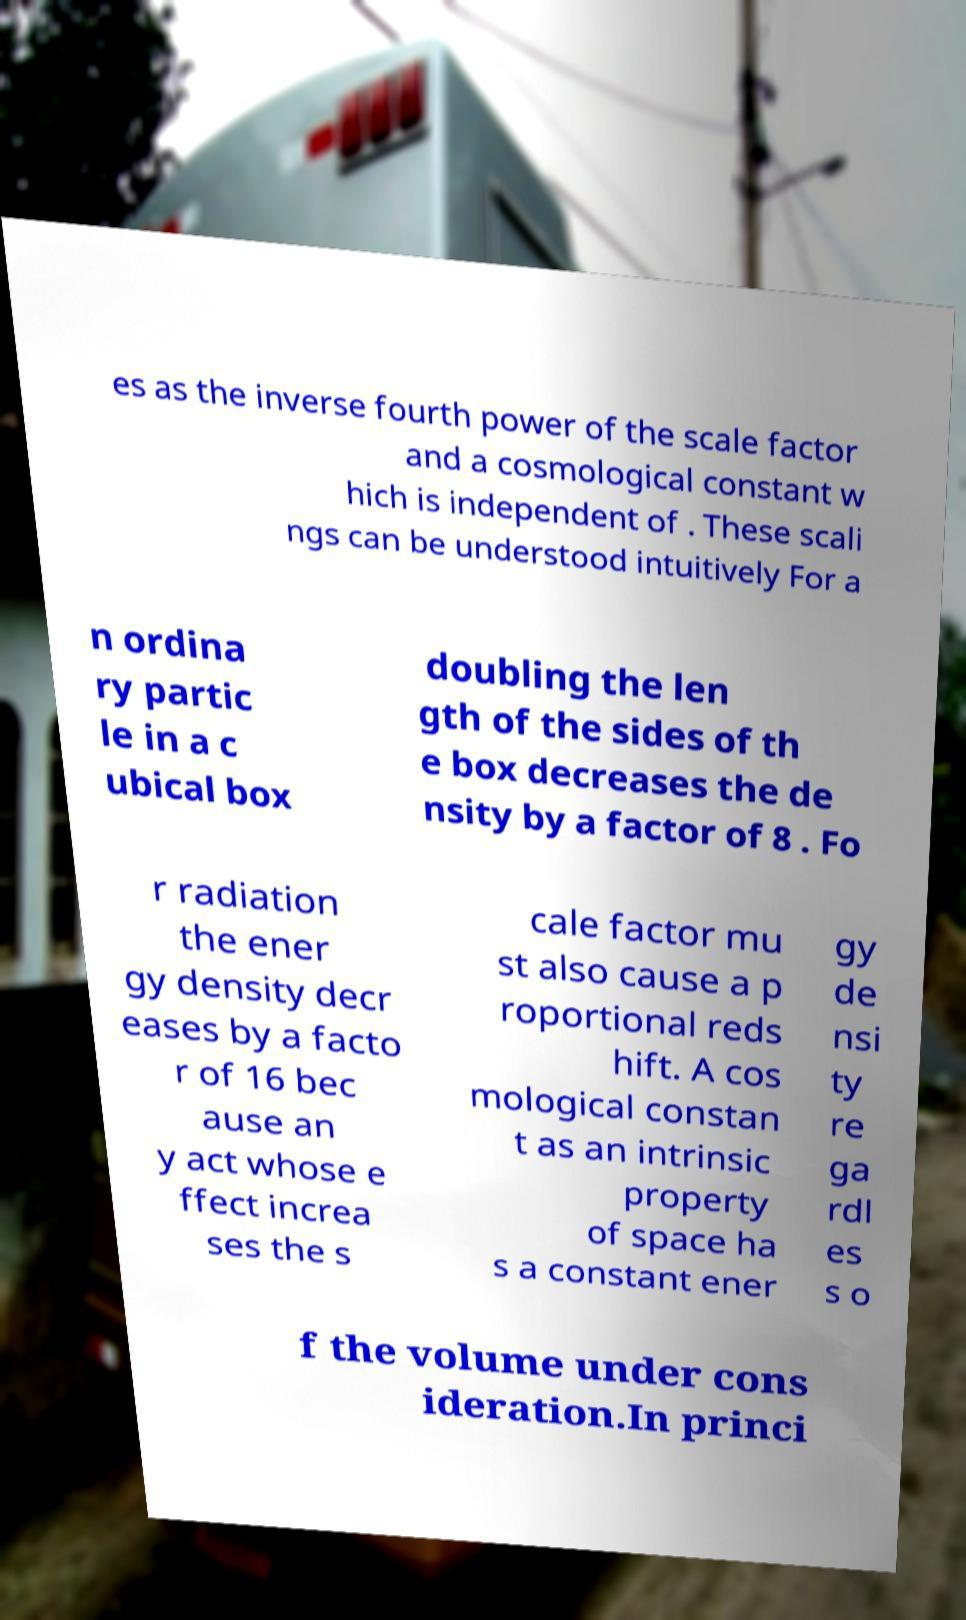Please identify and transcribe the text found in this image. es as the inverse fourth power of the scale factor and a cosmological constant w hich is independent of . These scali ngs can be understood intuitively For a n ordina ry partic le in a c ubical box doubling the len gth of the sides of th e box decreases the de nsity by a factor of 8 . Fo r radiation the ener gy density decr eases by a facto r of 16 bec ause an y act whose e ffect increa ses the s cale factor mu st also cause a p roportional reds hift. A cos mological constan t as an intrinsic property of space ha s a constant ener gy de nsi ty re ga rdl es s o f the volume under cons ideration.In princi 